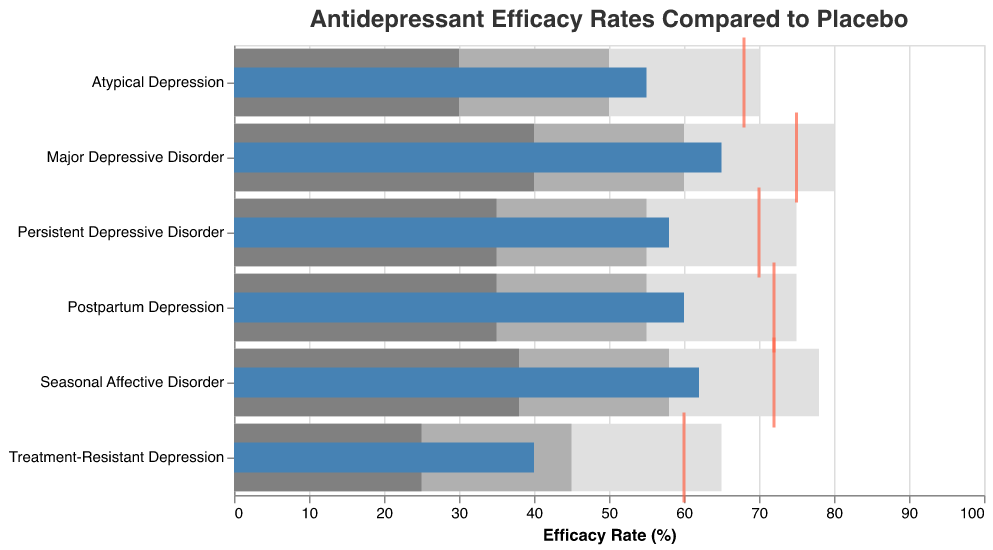What is the title of the figure? The title of the figure is located at the top and is typically larger and bolder than the other text. It reads "Antidepressant Efficacy Rates Compared to Placebo."
Answer: Antidepressant Efficacy Rates Compared to Placebo Which condition has the lowest actual efficacy rate? By examining the widths of the blue bars across all categories, we see that "Treatment-Resistant Depression" has the shortest blue bar, indicating it has the lowest actual efficacy rate.
Answer: Treatment-Resistant Depression What are the target efficacy rates for Major Depressive Disorder and Persistent Depressive Disorder? The target efficacy rates are represented by red ticks. For Major Depressive Disorder, the red tick is at 75%, and for Persistent Depressive Disorder, it is at 70%.
Answer: 75%, 70% Is the actual efficacy rate for Atypical Depression higher or lower than its mid-range? The actual efficacy rate for Atypical Depression is the length of the blue bar, which is at 55%. The mid-range, in grey bars, extends to 50%. Hence, the actual efficacy rate is higher.
Answer: Higher Compare the actual efficacy rate for Postpartum Depression to its target efficacy rate. For Postpartum Depression, the blue bar (actual efficacy) reaches 60%, whereas the red tick (target efficacy) is at 72%.
Answer: 60% vs 72% Which condition shows a larger difference between the actual efficacy rate and the high range value: Seasonal Affective Disorder or Postpartum Depression? For Seasonal Affective Disorder, the actual rate is 62% and the high range (light grey bar) is 78%, making the difference 16%. For Postpartum Depression, the actual rate is 60% and the high range is 75%, making the difference 15%.
Answer: Seasonal Affective Disorder Add the actual efficacy rates of Major Depressive Disorder and Seasonal Affective Disorder. What is the result? The actual efficacy rate for Major Depressive Disorder is 65%, and for Seasonal Affective Disorder, it is 62%. Adding these together gives 65 + 62 = 127.
Answer: 127 What is the average of the target efficacy rates for all conditions? The target efficacy rates for all conditions are 75%, 70%, 72%, 72%, 68%, and 60%. Summing these gives 75 + 70 + 72 + 72 + 68 + 60 = 417. Dividing by the number of conditions (6), the average is 417 / 6 ≈ 69.5.
Answer: 69.5 Which condition's actual efficacy rate falls closest to the midpoint of its mid-range? The actual efficacy rates and mid-ranges (represented by grey bars) need to be compared. 
- Major Depressive Disorder: Actual 65%, Midpoint (40+60)/2 = 50%.
- Persistent Depressive Disorder: Actual 58%, Midpoint (35+55)/2 = 45%.
- Seasonal Affective Disorder: Actual 62%, Midpoint (38+58)/2 = 48%.
- Postpartum Depression: Actual 60%, Midpoint (35+55)/2 = 45%.
- Atypical Depression: Actual 55%, Midpoint (30+50)/2 = 40%.
- Treatment-Resistant Depression: Actual 40%, Midpoint (25+45)/2 = 35%.
Comparing the differences, Persistent Depressive Disorder is the closest as 58% is closest to its midpoint 45%.
Answer: Persistent Depressive Disorder In which condition is the actual efficacy rate exactly equal to the high range value? By examining the lengths of the blue bars against the light grey bars, we see that no condition has an actual efficacy rate equal to the high range value.
Answer: None 